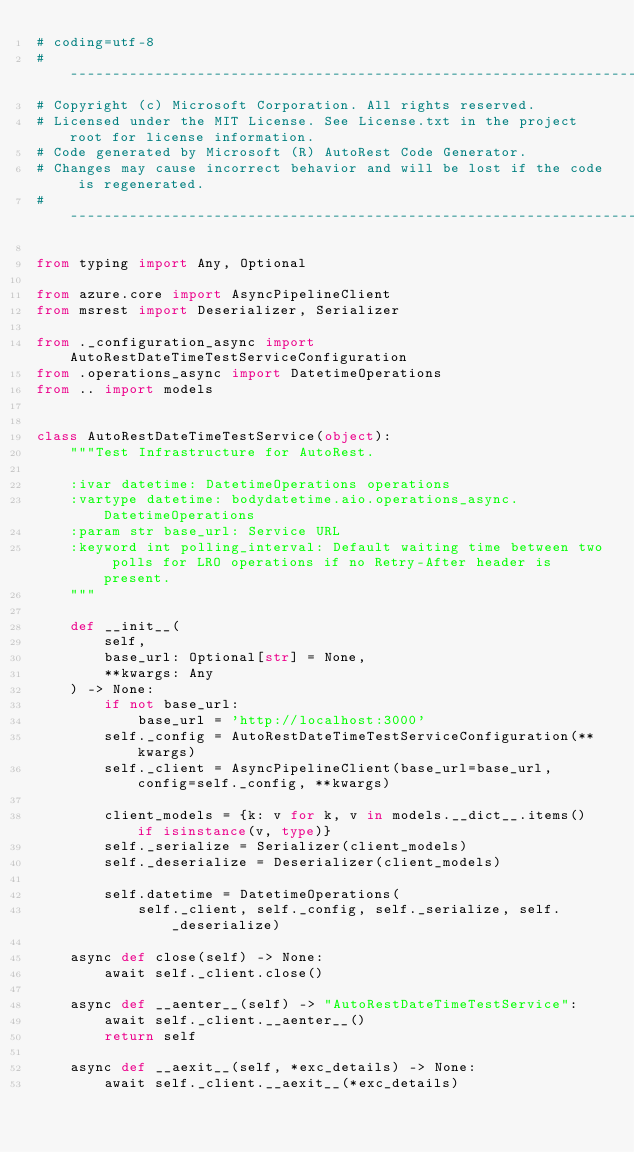Convert code to text. <code><loc_0><loc_0><loc_500><loc_500><_Python_># coding=utf-8
# --------------------------------------------------------------------------
# Copyright (c) Microsoft Corporation. All rights reserved.
# Licensed under the MIT License. See License.txt in the project root for license information.
# Code generated by Microsoft (R) AutoRest Code Generator.
# Changes may cause incorrect behavior and will be lost if the code is regenerated.
# --------------------------------------------------------------------------

from typing import Any, Optional

from azure.core import AsyncPipelineClient
from msrest import Deserializer, Serializer

from ._configuration_async import AutoRestDateTimeTestServiceConfiguration
from .operations_async import DatetimeOperations
from .. import models


class AutoRestDateTimeTestService(object):
    """Test Infrastructure for AutoRest.

    :ivar datetime: DatetimeOperations operations
    :vartype datetime: bodydatetime.aio.operations_async.DatetimeOperations
    :param str base_url: Service URL
    :keyword int polling_interval: Default waiting time between two polls for LRO operations if no Retry-After header is present.
    """

    def __init__(
        self,
        base_url: Optional[str] = None,
        **kwargs: Any
    ) -> None:
        if not base_url:
            base_url = 'http://localhost:3000'
        self._config = AutoRestDateTimeTestServiceConfiguration(**kwargs)
        self._client = AsyncPipelineClient(base_url=base_url, config=self._config, **kwargs)

        client_models = {k: v for k, v in models.__dict__.items() if isinstance(v, type)}
        self._serialize = Serializer(client_models)
        self._deserialize = Deserializer(client_models)

        self.datetime = DatetimeOperations(
            self._client, self._config, self._serialize, self._deserialize)

    async def close(self) -> None:
        await self._client.close()

    async def __aenter__(self) -> "AutoRestDateTimeTestService":
        await self._client.__aenter__()
        return self

    async def __aexit__(self, *exc_details) -> None:
        await self._client.__aexit__(*exc_details)
</code> 